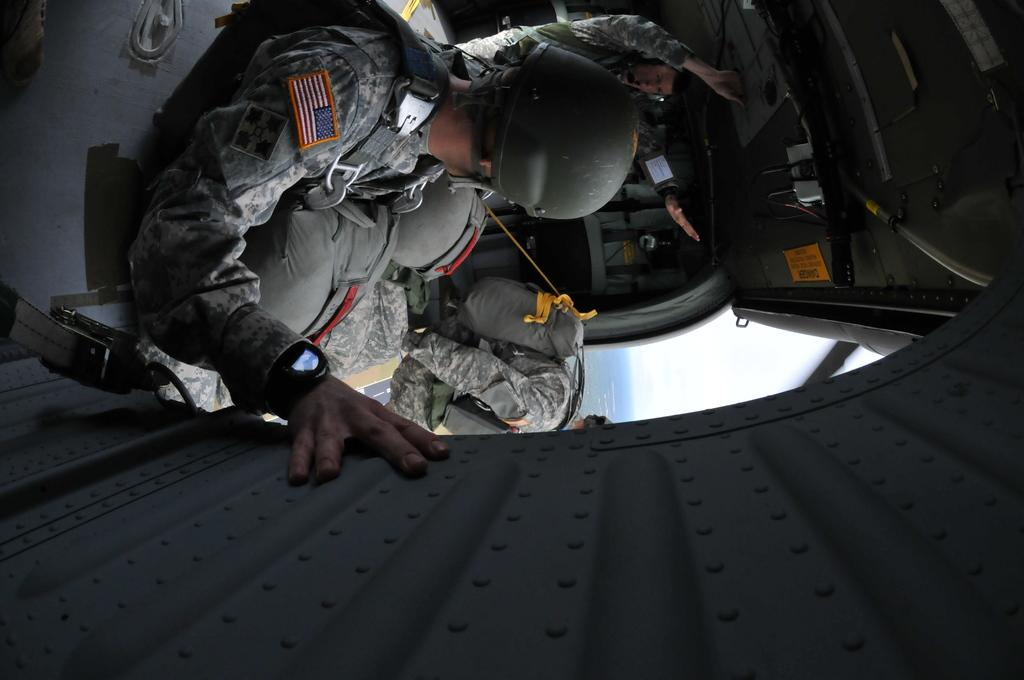How many people are in the image? There are three people in the image. What can be seen in the image besides the people? There is a helicopter in the image. What is one of the people doing in the image? One person is jumping from the helicopter. Can you describe the rope in the image? There is a rope tied to a bag in the image. What type of necklace is the person wearing in the image? There is no necklace visible in the image. How does the turkey contribute to the scene in the image? There is no turkey present in the image. 